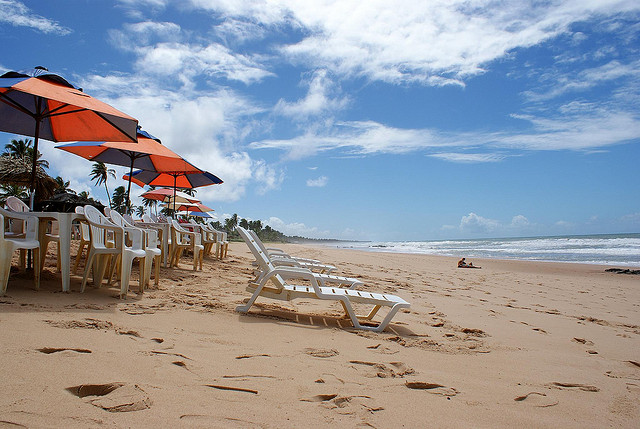What type of trees are in this picture? The type of trees visible in this image are palm trees, characterized by their tall, slender trunks and large, fanning fronds. They are commonly associated with tropical beach scenes. 